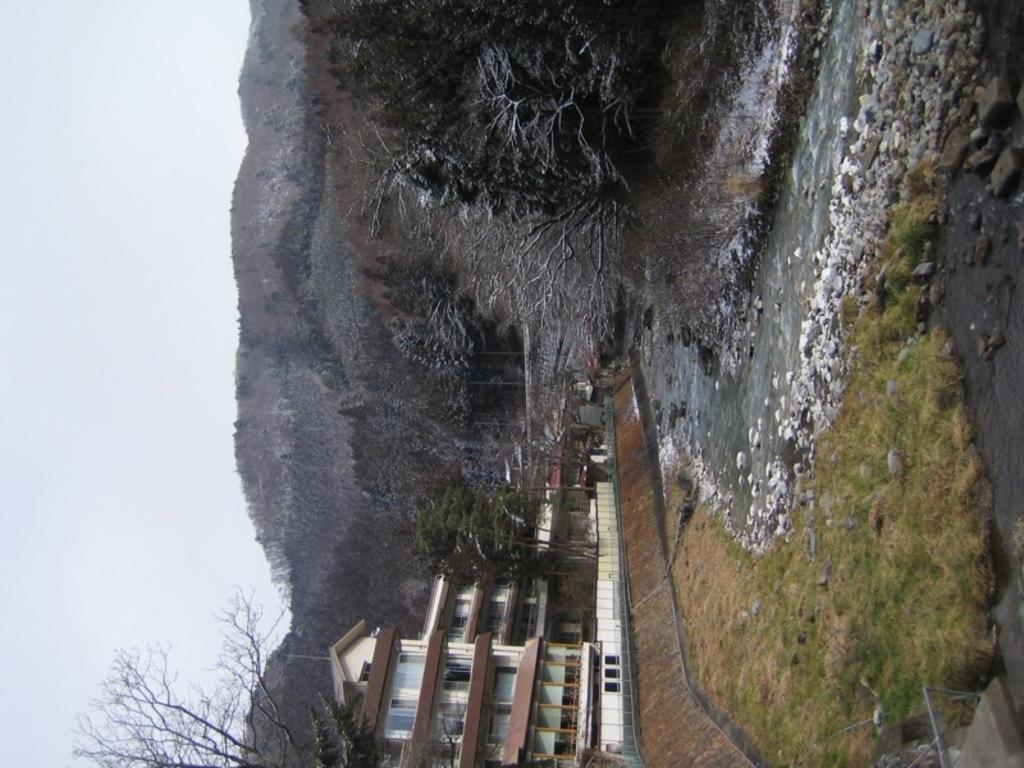Can you describe this image briefly? In this image in the front there's grass on the ground and at the bottom there are buildings, trees. In the background there are trees and mountains and in the center there is water. 